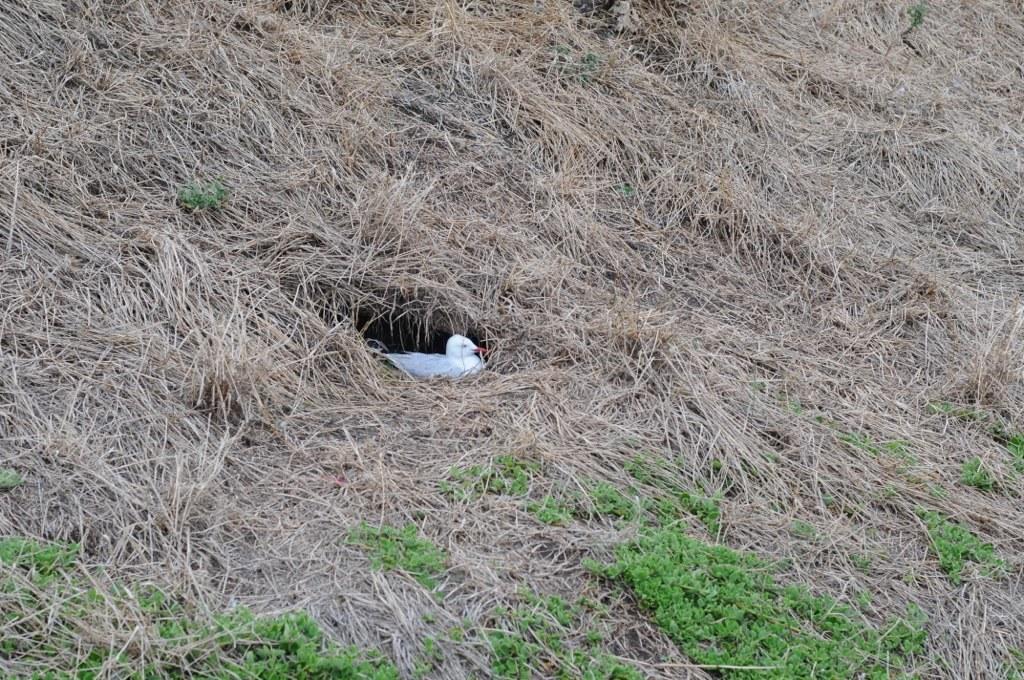Could you give a brief overview of what you see in this image? This picture was taken from the outside and in this image we can see a pigeon on surface of the grass. 